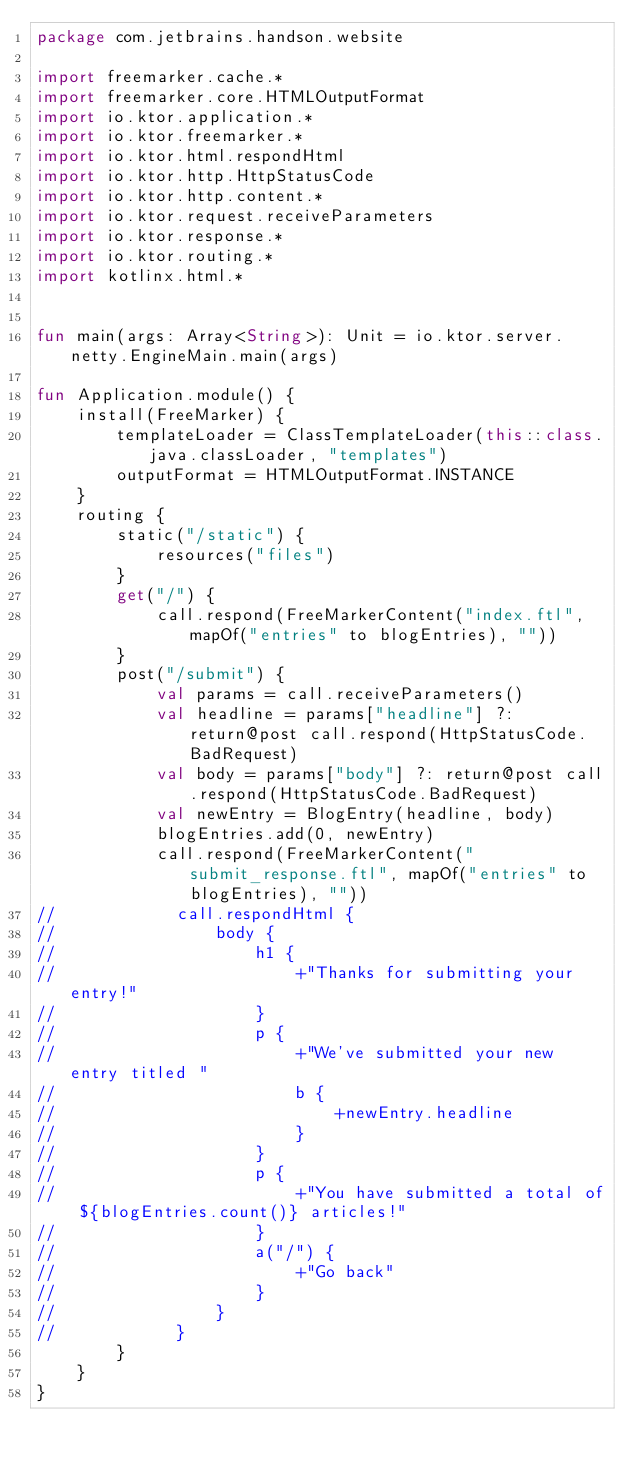<code> <loc_0><loc_0><loc_500><loc_500><_Kotlin_>package com.jetbrains.handson.website

import freemarker.cache.*
import freemarker.core.HTMLOutputFormat
import io.ktor.application.*
import io.ktor.freemarker.*
import io.ktor.html.respondHtml
import io.ktor.http.HttpStatusCode
import io.ktor.http.content.*
import io.ktor.request.receiveParameters
import io.ktor.response.*
import io.ktor.routing.*
import kotlinx.html.*


fun main(args: Array<String>): Unit = io.ktor.server.netty.EngineMain.main(args)

fun Application.module() {
    install(FreeMarker) {
        templateLoader = ClassTemplateLoader(this::class.java.classLoader, "templates")
        outputFormat = HTMLOutputFormat.INSTANCE
    }
    routing {
        static("/static") {
            resources("files")
        }
        get("/") {
            call.respond(FreeMarkerContent("index.ftl", mapOf("entries" to blogEntries), ""))
        }
        post("/submit") {
            val params = call.receiveParameters()
            val headline = params["headline"] ?: return@post call.respond(HttpStatusCode.BadRequest)
            val body = params["body"] ?: return@post call.respond(HttpStatusCode.BadRequest)
            val newEntry = BlogEntry(headline, body)
            blogEntries.add(0, newEntry)
            call.respond(FreeMarkerContent("submit_response.ftl", mapOf("entries" to blogEntries), ""))
//            call.respondHtml {
//                body {
//                    h1 {
//                        +"Thanks for submitting your entry!"
//                    }
//                    p {
//                        +"We've submitted your new entry titled "
//                        b {
//                            +newEntry.headline
//                        }
//                    }
//                    p {
//                        +"You have submitted a total of ${blogEntries.count()} articles!"
//                    }
//                    a("/") {
//                        +"Go back"
//                    }
//                }
//            }
        }
    }
}
</code> 